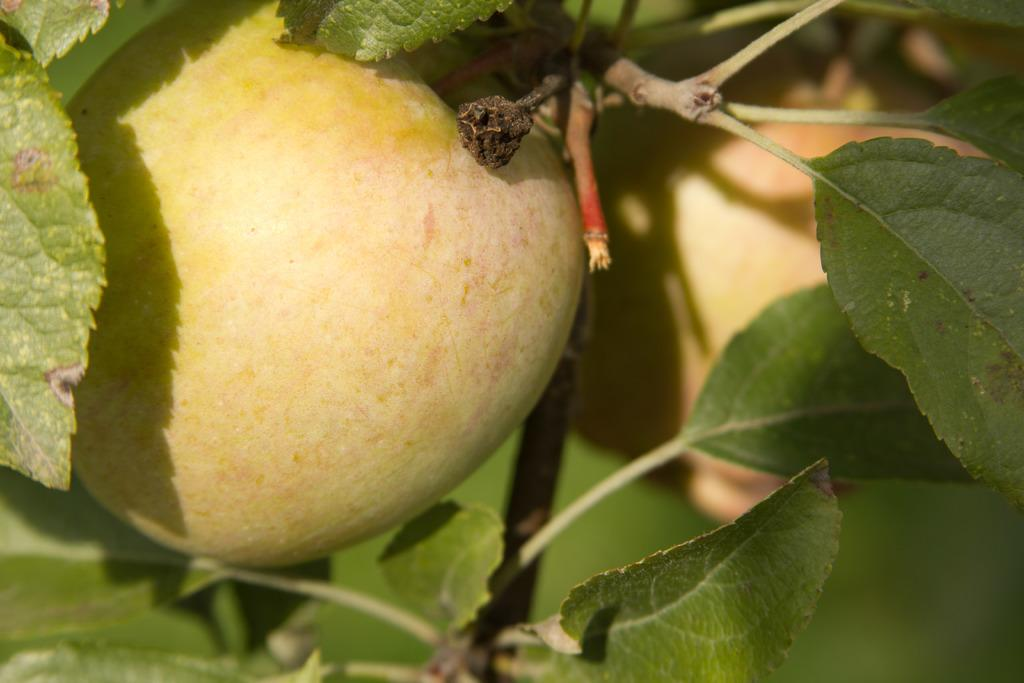What type of food items are present in the image? There are fruits in the image. What type of vegetation is visible in the image? There are green leaves in the image. What type of field can be seen in the image? There is no field present in the image; it only features fruits and green leaves. What thoughts are being expressed by the cattle in the image? There are no cattle or thoughts present in the image. 